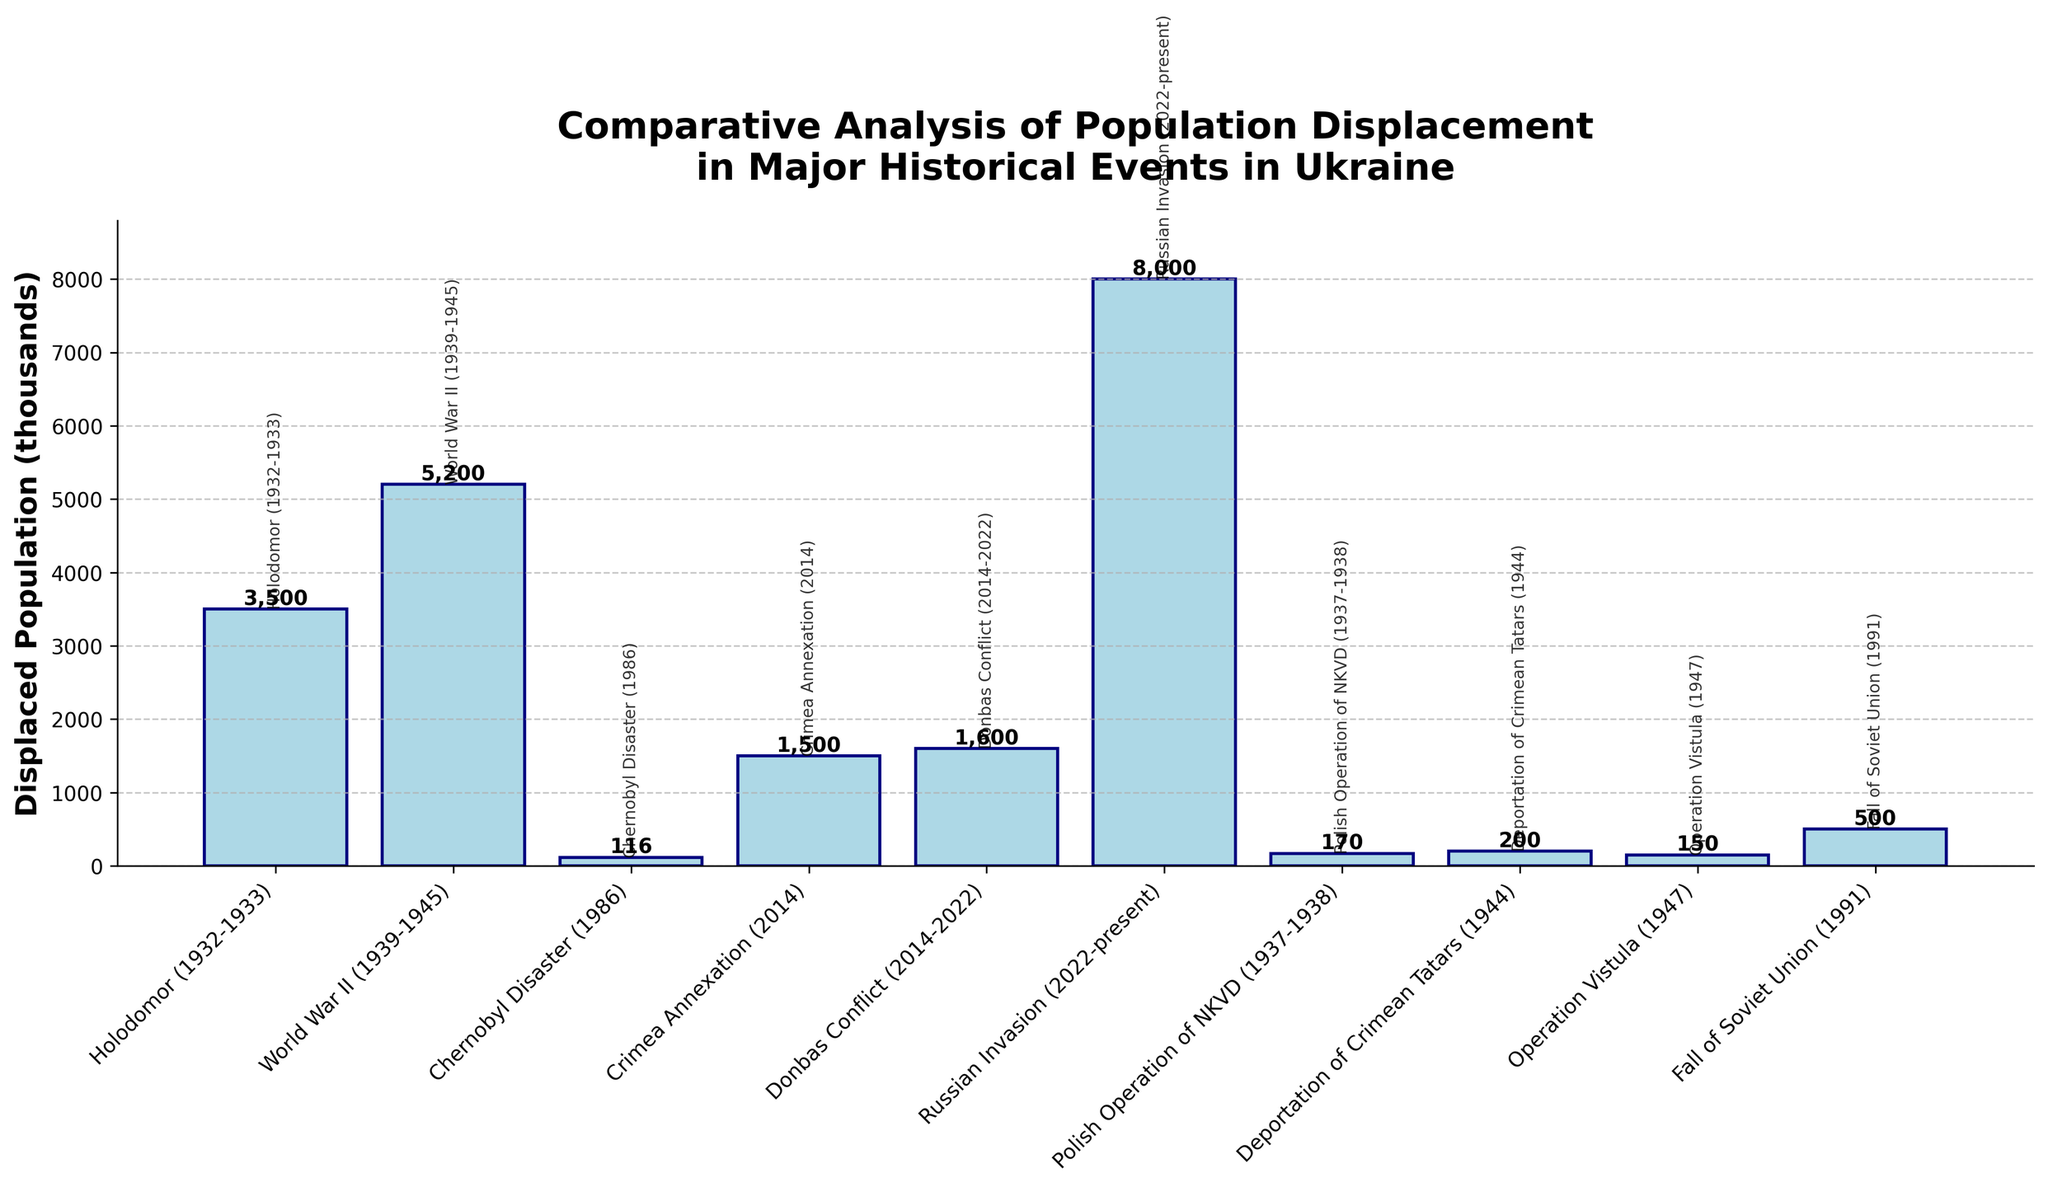Which event had the highest displaced population? The bar corresponding to the "Russian Invasion (2022-present)" is the tallest, indicating the highest displaced population of 8,000 thousand.
Answer: Russian Invasion (2022-present) Which events had a displaced population greater than 3,000 thousand? By observing the bars, we see that "Holodomor (1932-1933)," "World War II (1939-1945)," and "Russian Invasion (2022-present)" have heights indicating populations greater than 3,000 thousand.
Answer: Holodomor (1932-1933), World War II (1939-1945), Russian Invasion (2022-present) What is the combined displaced population of the Chernobyl Disaster, Operation Vistula, and the Deportation of Crimean Tatars? Summing the displaced populations: Chernobyl Disaster (116k) + Operation Vistula (150k) + Deportation of Crimean Tatars (200k) gives 116 + 150 + 200 = 466 thousand.
Answer: 466 thousand Which event displaced fewer people, the Crimea Annexation or the Donbas Conflict? By comparing bar heights, the "Crimea Annexation (2014)" displaced 1,500 thousand people while the "Donbas Conflict (2014-2022)" displaced 1,600 thousand. Therefore, Crimea Annexation displaced fewer people.
Answer: Crimea Annexation Are there events with a displaced population of less than 200 thousand? If yes, list them. By checking bars with heights below 200 thousand, the "Chernobyl Disaster (1986)" (116k), "Polish Operation of NKVD (1937-1938)" (170k), and "Operation Vistula (1947)" (150k) fall into this category.
Answer: Chernobyl Disaster, Polish Operation of NKVD, Operation Vistula What is the difference in displaced population between World War II and the Fall of the Soviet Union? Subtracting the displaced population of the Fall of the Soviet Union (500k) from World War II (5,200k), we get 5,200 - 500 = 4,700 thousand.
Answer: 4,700 thousand Which event has a visually smaller bar compared to the Holodomor and the Russian Invasion, but has significantly affected population displacement? The "World War II (1939-1945)" bar is visually smaller compared to the Russian Invasion's bar, but it significantly affected displacement with 5,200 thousand people.
Answer: World War II Identify the event with the shortest bar on the chart. The shortest bar corresponds to the "Chernobyl Disaster (1986)" with 116 thousand displaced.
Answer: Chernobyl Disaster 